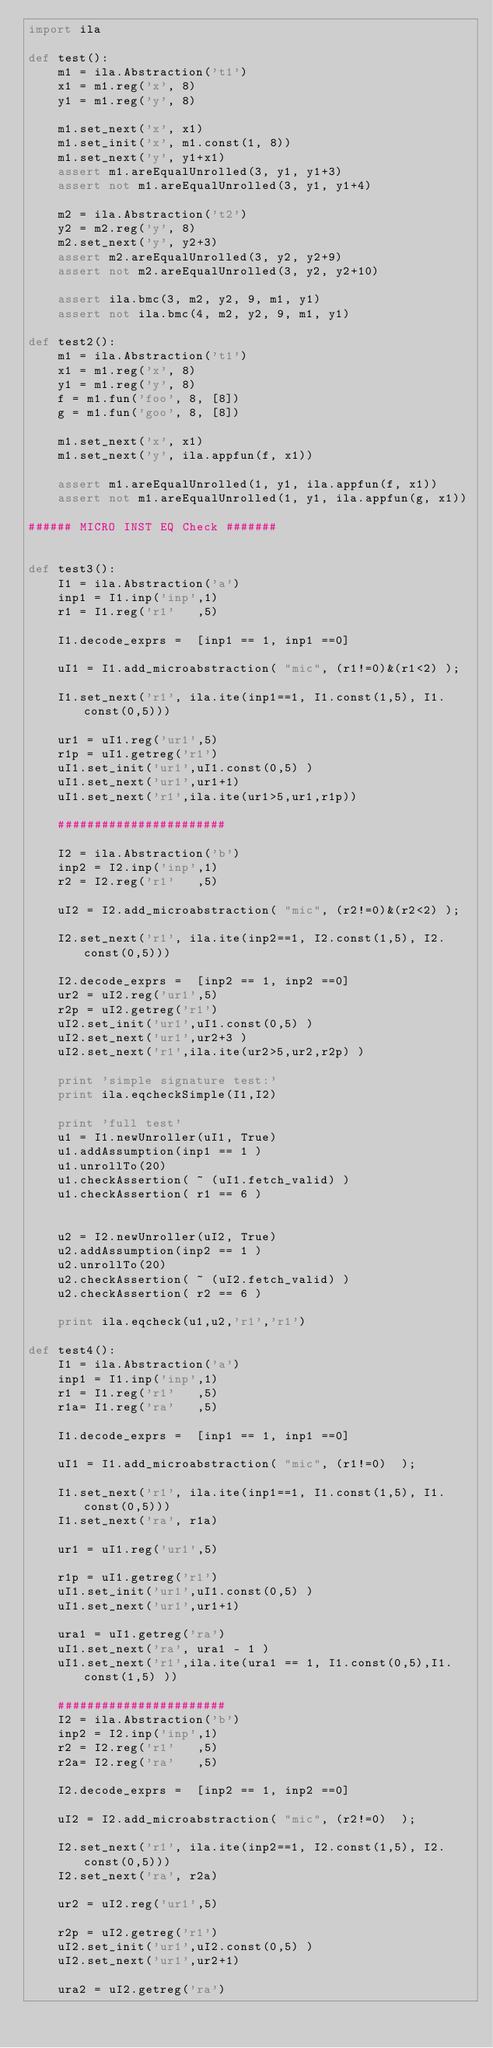<code> <loc_0><loc_0><loc_500><loc_500><_Python_>import ila

def test():
    m1 = ila.Abstraction('t1')
    x1 = m1.reg('x', 8)
    y1 = m1.reg('y', 8)

    m1.set_next('x', x1)
    m1.set_init('x', m1.const(1, 8))
    m1.set_next('y', y1+x1)
    assert m1.areEqualUnrolled(3, y1, y1+3)
    assert not m1.areEqualUnrolled(3, y1, y1+4)

    m2 = ila.Abstraction('t2')
    y2 = m2.reg('y', 8)
    m2.set_next('y', y2+3)
    assert m2.areEqualUnrolled(3, y2, y2+9)
    assert not m2.areEqualUnrolled(3, y2, y2+10)

    assert ila.bmc(3, m2, y2, 9, m1, y1)
    assert not ila.bmc(4, m2, y2, 9, m1, y1)

def test2():
    m1 = ila.Abstraction('t1')
    x1 = m1.reg('x', 8)
    y1 = m1.reg('y', 8)
    f = m1.fun('foo', 8, [8])
    g = m1.fun('goo', 8, [8])

    m1.set_next('x', x1)
    m1.set_next('y', ila.appfun(f, x1))

    assert m1.areEqualUnrolled(1, y1, ila.appfun(f, x1))
    assert not m1.areEqualUnrolled(1, y1, ila.appfun(g, x1))

###### MICRO INST EQ Check #######


def test3():
    I1 = ila.Abstraction('a')
    inp1 = I1.inp('inp',1)
    r1 = I1.reg('r1'   ,5)
    
    I1.decode_exprs =  [inp1 == 1, inp1 ==0] 
    
    uI1 = I1.add_microabstraction( "mic", (r1!=0)&(r1<2) );
    
    I1.set_next('r1', ila.ite(inp1==1, I1.const(1,5), I1.const(0,5)))
    
    ur1 = uI1.reg('ur1',5)
    r1p = uI1.getreg('r1')
    uI1.set_init('ur1',uI1.const(0,5) )
    uI1.set_next('ur1',ur1+1)
    uI1.set_next('r1',ila.ite(ur1>5,ur1,r1p))
    
    #######################
    
    I2 = ila.Abstraction('b')
    inp2 = I2.inp('inp',1)
    r2 = I2.reg('r1'   ,5)
    
    uI2 = I2.add_microabstraction( "mic", (r2!=0)&(r2<2) );
    
    I2.set_next('r1', ila.ite(inp2==1, I2.const(1,5), I2.const(0,5)))
    
    I2.decode_exprs =  [inp2 == 1, inp2 ==0]
    ur2 = uI2.reg('ur1',5)
    r2p = uI2.getreg('r1')
    uI2.set_init('ur1',uI1.const(0,5) )
    uI2.set_next('ur1',ur2+3 )
    uI2.set_next('r1',ila.ite(ur2>5,ur2,r2p) )

    print 'simple signature test:'
    print ila.eqcheckSimple(I1,I2)
    
    print 'full test'
    u1 = I1.newUnroller(uI1, True)
    u1.addAssumption(inp1 == 1 )
    u1.unrollTo(20)
    u1.checkAssertion( ~ (uI1.fetch_valid) )
    u1.checkAssertion( r1 == 6 )
    
    
    u2 = I2.newUnroller(uI2, True)
    u2.addAssumption(inp2 == 1 )
    u2.unrollTo(20)
    u2.checkAssertion( ~ (uI2.fetch_valid) )
    u2.checkAssertion( r2 == 6 )
    
    print ila.eqcheck(u1,u2,'r1','r1')

def test4():
    I1 = ila.Abstraction('a')
    inp1 = I1.inp('inp',1)
    r1 = I1.reg('r1'   ,5)
    r1a= I1.reg('ra'   ,5)
    
    I1.decode_exprs =  [inp1 == 1, inp1 ==0] 
    
    uI1 = I1.add_microabstraction( "mic", (r1!=0)  );
    
    I1.set_next('r1', ila.ite(inp1==1, I1.const(1,5), I1.const(0,5)))
    I1.set_next('ra', r1a)
    
    ur1 = uI1.reg('ur1',5)
    
    r1p = uI1.getreg('r1')
    uI1.set_init('ur1',uI1.const(0,5) )
    uI1.set_next('ur1',ur1+1)
    
    ura1 = uI1.getreg('ra')
    uI1.set_next('ra', ura1 - 1 )    
    uI1.set_next('r1',ila.ite(ura1 == 1, I1.const(0,5),I1.const(1,5) ))
    
    #######################
    I2 = ila.Abstraction('b')
    inp2 = I2.inp('inp',1)
    r2 = I2.reg('r1'   ,5)
    r2a= I2.reg('ra'   ,5)
    
    I2.decode_exprs =  [inp2 == 1, inp2 ==0] 
    
    uI2 = I2.add_microabstraction( "mic", (r2!=0)  );
    
    I2.set_next('r1', ila.ite(inp2==1, I2.const(1,5), I2.const(0,5)))
    I2.set_next('ra', r2a)
    
    ur2 = uI2.reg('ur1',5)
    
    r2p = uI2.getreg('r1')
    uI2.set_init('ur1',uI2.const(0,5) )
    uI2.set_next('ur1',ur2+1)
    
    ura2 = uI2.getreg('ra')</code> 